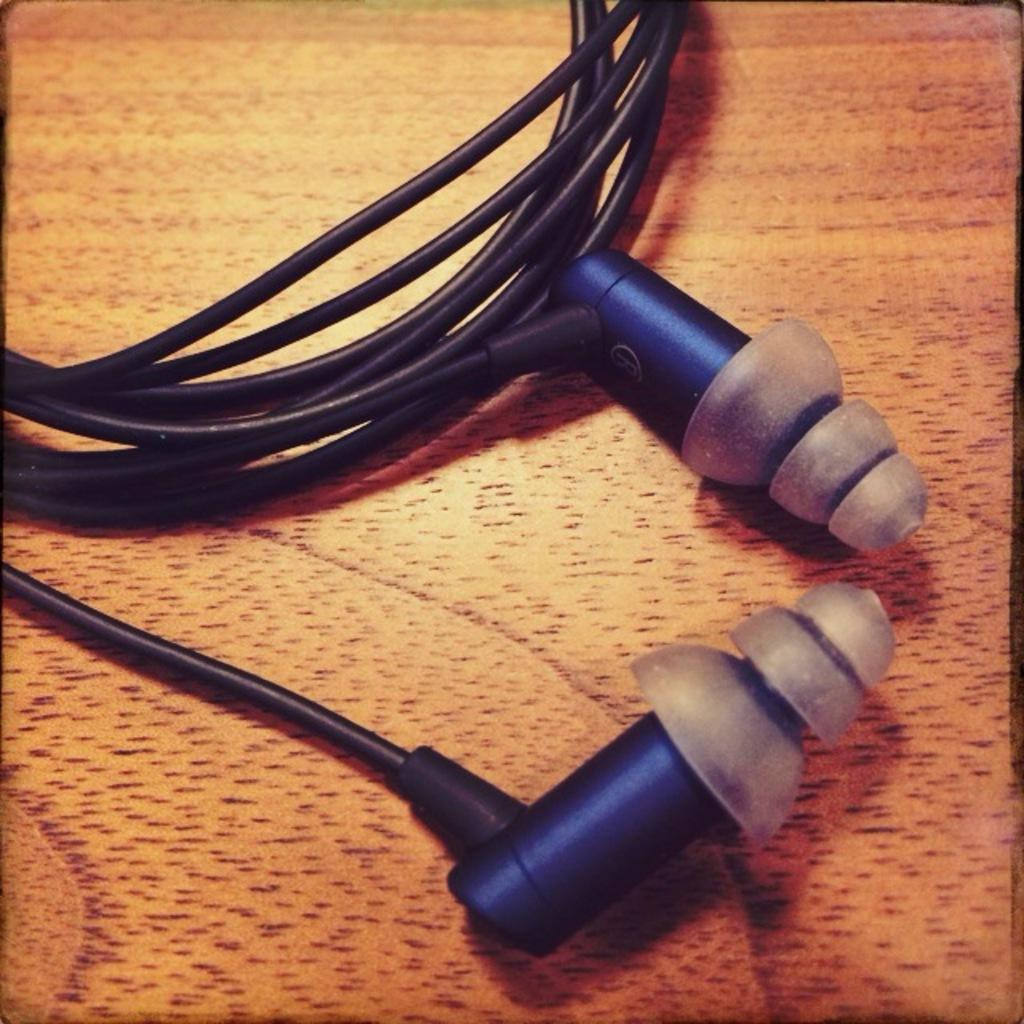What is the main object in the image? There is a headphone in the image. Where is the headphone placed? The headphone is on a surface. What is the color of the surface? The surface is black in color. Are there any other colors visible on the surface? Yes, the surface has a blue color as well. How many tomatoes are on the headphone in the image? There are no tomatoes present in the image. Is the crayon used to draw on the headphone in the image? There is no crayon or drawing visible on the headphone in the image. 